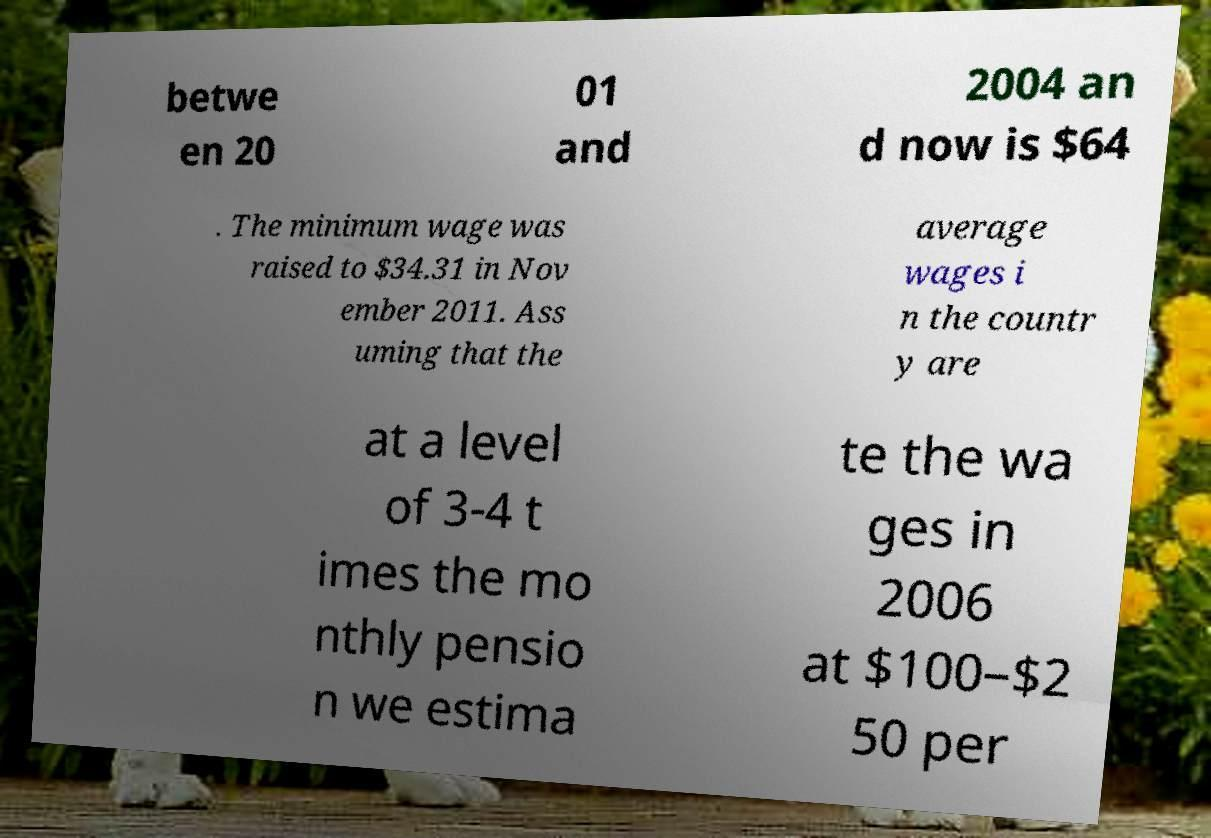There's text embedded in this image that I need extracted. Can you transcribe it verbatim? betwe en 20 01 and 2004 an d now is $64 . The minimum wage was raised to $34.31 in Nov ember 2011. Ass uming that the average wages i n the countr y are at a level of 3-4 t imes the mo nthly pensio n we estima te the wa ges in 2006 at $100–$2 50 per 